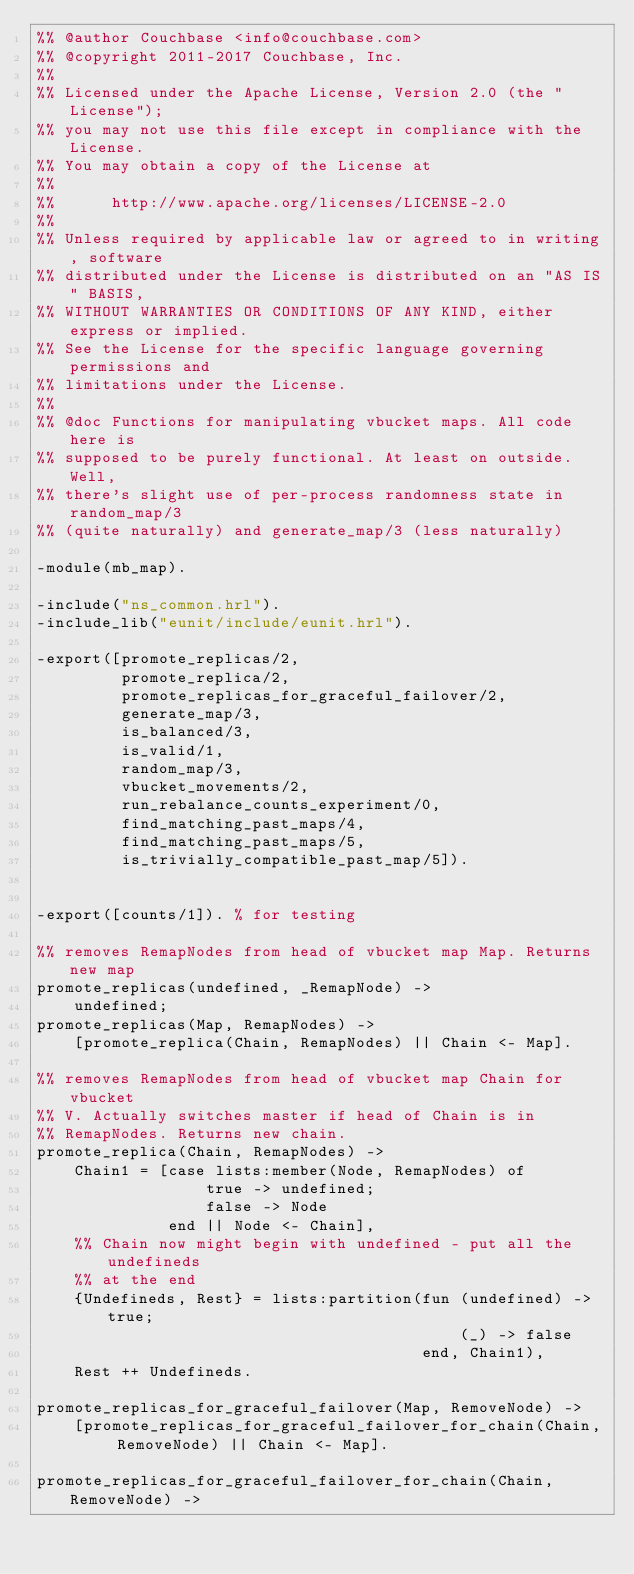<code> <loc_0><loc_0><loc_500><loc_500><_Erlang_>%% @author Couchbase <info@couchbase.com>
%% @copyright 2011-2017 Couchbase, Inc.
%%
%% Licensed under the Apache License, Version 2.0 (the "License");
%% you may not use this file except in compliance with the License.
%% You may obtain a copy of the License at
%%
%%      http://www.apache.org/licenses/LICENSE-2.0
%%
%% Unless required by applicable law or agreed to in writing, software
%% distributed under the License is distributed on an "AS IS" BASIS,
%% WITHOUT WARRANTIES OR CONDITIONS OF ANY KIND, either express or implied.
%% See the License for the specific language governing permissions and
%% limitations under the License.
%%
%% @doc Functions for manipulating vbucket maps. All code here is
%% supposed to be purely functional. At least on outside. Well,
%% there's slight use of per-process randomness state in random_map/3
%% (quite naturally) and generate_map/3 (less naturally)

-module(mb_map).

-include("ns_common.hrl").
-include_lib("eunit/include/eunit.hrl").

-export([promote_replicas/2,
         promote_replica/2,
         promote_replicas_for_graceful_failover/2,
         generate_map/3,
         is_balanced/3,
         is_valid/1,
         random_map/3,
         vbucket_movements/2,
         run_rebalance_counts_experiment/0,
         find_matching_past_maps/4,
         find_matching_past_maps/5,
         is_trivially_compatible_past_map/5]).


-export([counts/1]). % for testing

%% removes RemapNodes from head of vbucket map Map. Returns new map
promote_replicas(undefined, _RemapNode) ->
    undefined;
promote_replicas(Map, RemapNodes) ->
    [promote_replica(Chain, RemapNodes) || Chain <- Map].

%% removes RemapNodes from head of vbucket map Chain for vbucket
%% V. Actually switches master if head of Chain is in
%% RemapNodes. Returns new chain.
promote_replica(Chain, RemapNodes) ->
    Chain1 = [case lists:member(Node, RemapNodes) of
                  true -> undefined;
                  false -> Node
              end || Node <- Chain],
    %% Chain now might begin with undefined - put all the undefineds
    %% at the end
    {Undefineds, Rest} = lists:partition(fun (undefined) -> true;
                                             (_) -> false
                                         end, Chain1),
    Rest ++ Undefineds.

promote_replicas_for_graceful_failover(Map, RemoveNode) ->
    [promote_replicas_for_graceful_failover_for_chain(Chain, RemoveNode) || Chain <- Map].

promote_replicas_for_graceful_failover_for_chain(Chain, RemoveNode) -></code> 